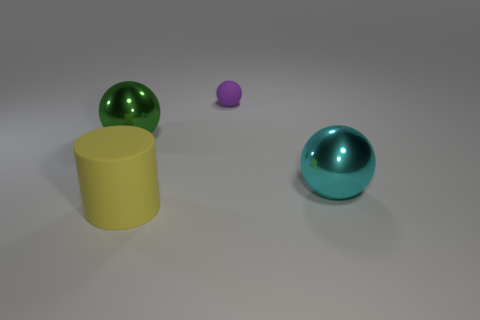Add 3 purple metallic cubes. How many objects exist? 7 Subtract all balls. How many objects are left? 1 Add 4 big spheres. How many big spheres are left? 6 Add 4 large yellow rubber things. How many large yellow rubber things exist? 5 Subtract 0 gray cubes. How many objects are left? 4 Subtract all large cyan shiny things. Subtract all large blue cylinders. How many objects are left? 3 